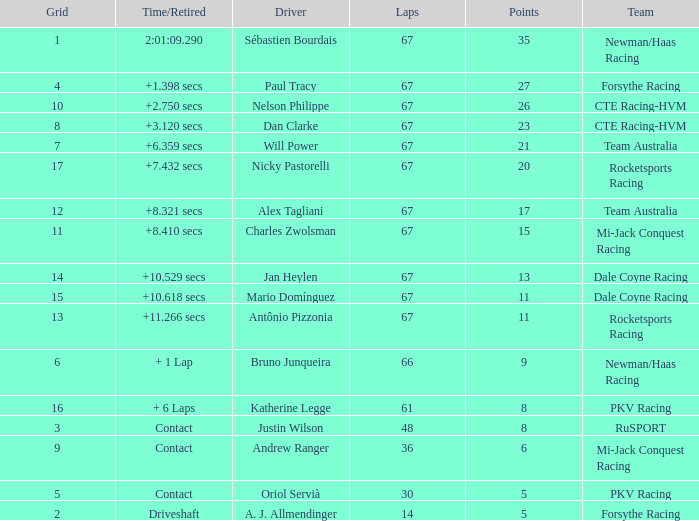What was time/retired with less than 67 laps and 6 points? Contact. 